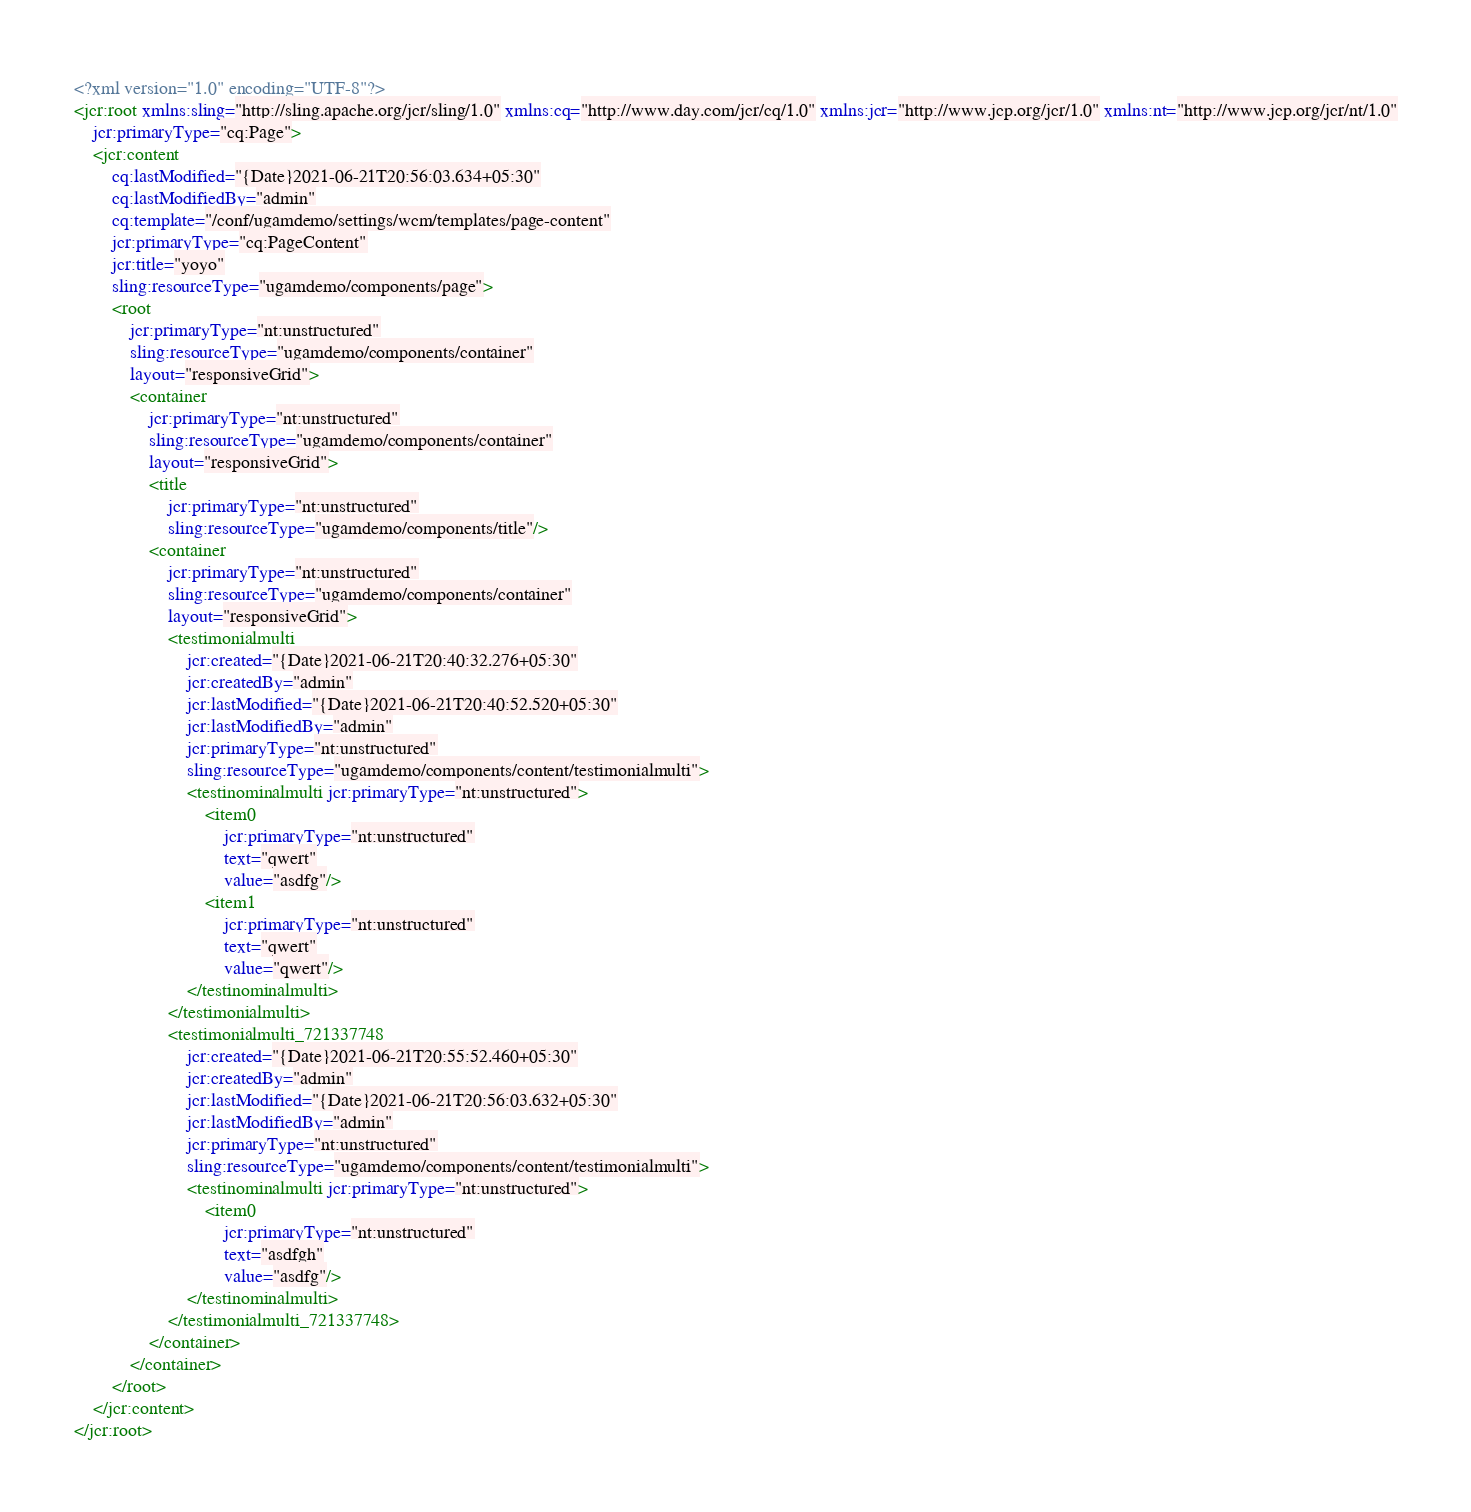<code> <loc_0><loc_0><loc_500><loc_500><_XML_><?xml version="1.0" encoding="UTF-8"?>
<jcr:root xmlns:sling="http://sling.apache.org/jcr/sling/1.0" xmlns:cq="http://www.day.com/jcr/cq/1.0" xmlns:jcr="http://www.jcp.org/jcr/1.0" xmlns:nt="http://www.jcp.org/jcr/nt/1.0"
    jcr:primaryType="cq:Page">
    <jcr:content
        cq:lastModified="{Date}2021-06-21T20:56:03.634+05:30"
        cq:lastModifiedBy="admin"
        cq:template="/conf/ugamdemo/settings/wcm/templates/page-content"
        jcr:primaryType="cq:PageContent"
        jcr:title="yoyo"
        sling:resourceType="ugamdemo/components/page">
        <root
            jcr:primaryType="nt:unstructured"
            sling:resourceType="ugamdemo/components/container"
            layout="responsiveGrid">
            <container
                jcr:primaryType="nt:unstructured"
                sling:resourceType="ugamdemo/components/container"
                layout="responsiveGrid">
                <title
                    jcr:primaryType="nt:unstructured"
                    sling:resourceType="ugamdemo/components/title"/>
                <container
                    jcr:primaryType="nt:unstructured"
                    sling:resourceType="ugamdemo/components/container"
                    layout="responsiveGrid">
                    <testimonialmulti
                        jcr:created="{Date}2021-06-21T20:40:32.276+05:30"
                        jcr:createdBy="admin"
                        jcr:lastModified="{Date}2021-06-21T20:40:52.520+05:30"
                        jcr:lastModifiedBy="admin"
                        jcr:primaryType="nt:unstructured"
                        sling:resourceType="ugamdemo/components/content/testimonialmulti">
                        <testinominalmulti jcr:primaryType="nt:unstructured">
                            <item0
                                jcr:primaryType="nt:unstructured"
                                text="qwert"
                                value="asdfg"/>
                            <item1
                                jcr:primaryType="nt:unstructured"
                                text="qwert"
                                value="qwert"/>
                        </testinominalmulti>
                    </testimonialmulti>
                    <testimonialmulti_721337748
                        jcr:created="{Date}2021-06-21T20:55:52.460+05:30"
                        jcr:createdBy="admin"
                        jcr:lastModified="{Date}2021-06-21T20:56:03.632+05:30"
                        jcr:lastModifiedBy="admin"
                        jcr:primaryType="nt:unstructured"
                        sling:resourceType="ugamdemo/components/content/testimonialmulti">
                        <testinominalmulti jcr:primaryType="nt:unstructured">
                            <item0
                                jcr:primaryType="nt:unstructured"
                                text="asdfgh"
                                value="asdfg"/>
                        </testinominalmulti>
                    </testimonialmulti_721337748>
                </container>
            </container>
        </root>
    </jcr:content>
</jcr:root>
</code> 